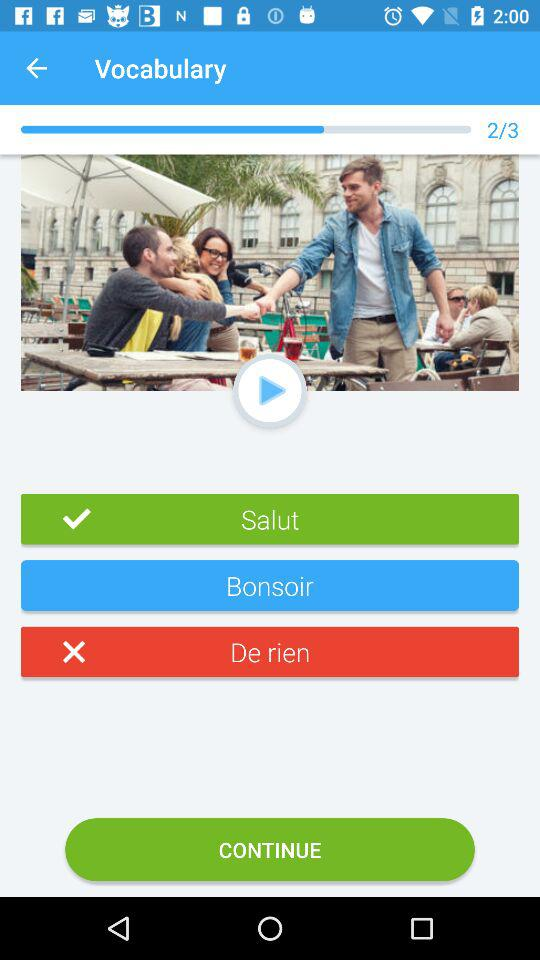How many questions are there in total in "Vocabulary"? There are 3 questions. 